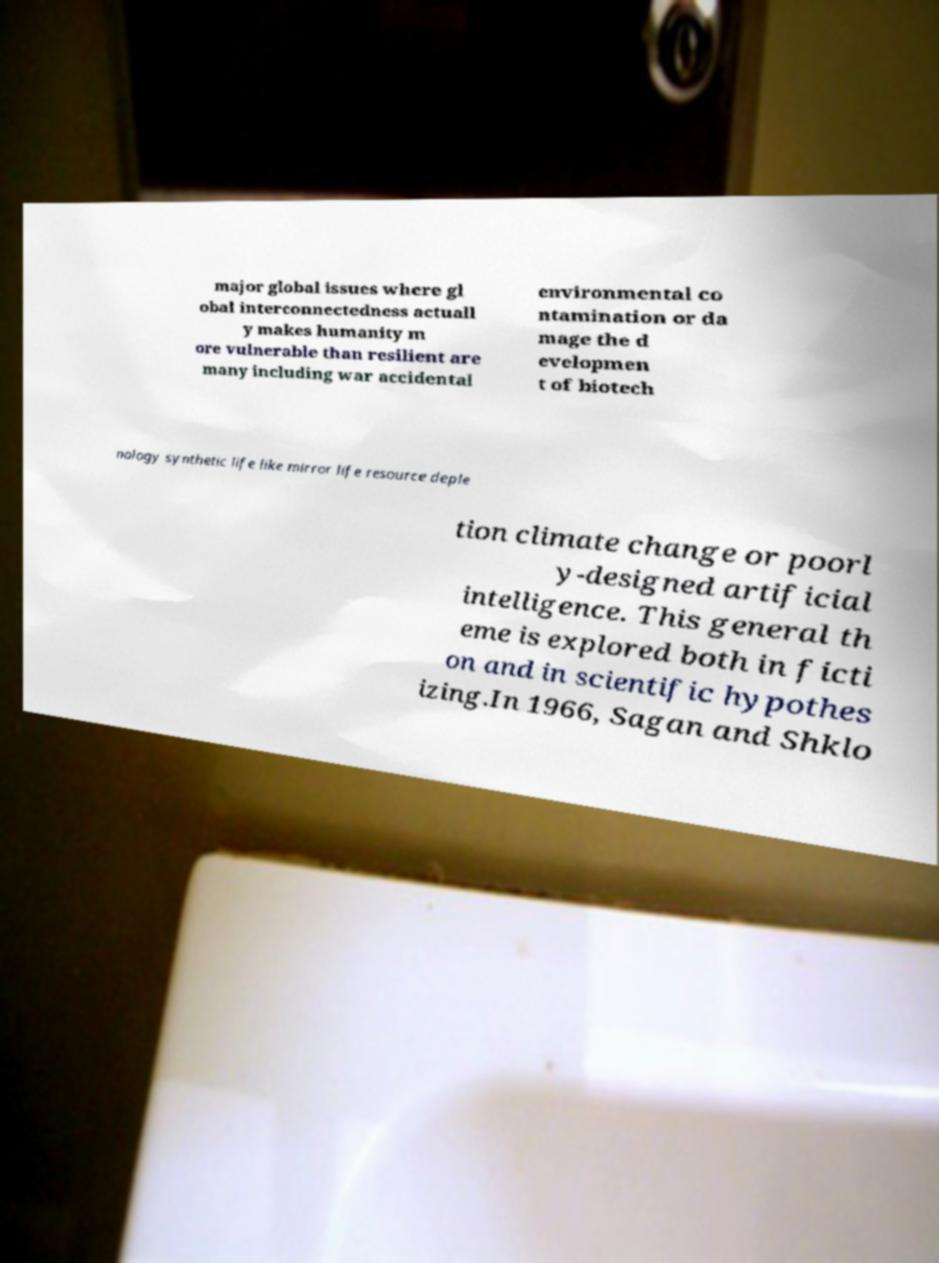Could you assist in decoding the text presented in this image and type it out clearly? major global issues where gl obal interconnectedness actuall y makes humanity m ore vulnerable than resilient are many including war accidental environmental co ntamination or da mage the d evelopmen t of biotech nology synthetic life like mirror life resource deple tion climate change or poorl y-designed artificial intelligence. This general th eme is explored both in ficti on and in scientific hypothes izing.In 1966, Sagan and Shklo 